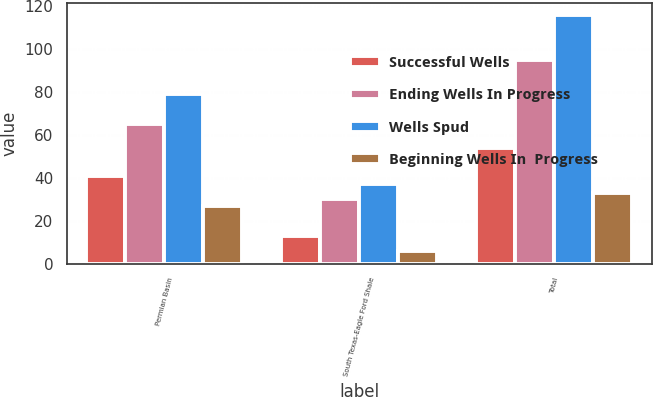Convert chart. <chart><loc_0><loc_0><loc_500><loc_500><stacked_bar_chart><ecel><fcel>Permian Basin<fcel>South Texas-Eagle Ford Shale<fcel>Total<nl><fcel>Successful Wells<fcel>41<fcel>13<fcel>54<nl><fcel>Ending Wells In Progress<fcel>65<fcel>30<fcel>95<nl><fcel>Wells Spud<fcel>79<fcel>37<fcel>116<nl><fcel>Beginning Wells In  Progress<fcel>27<fcel>6<fcel>33<nl></chart> 